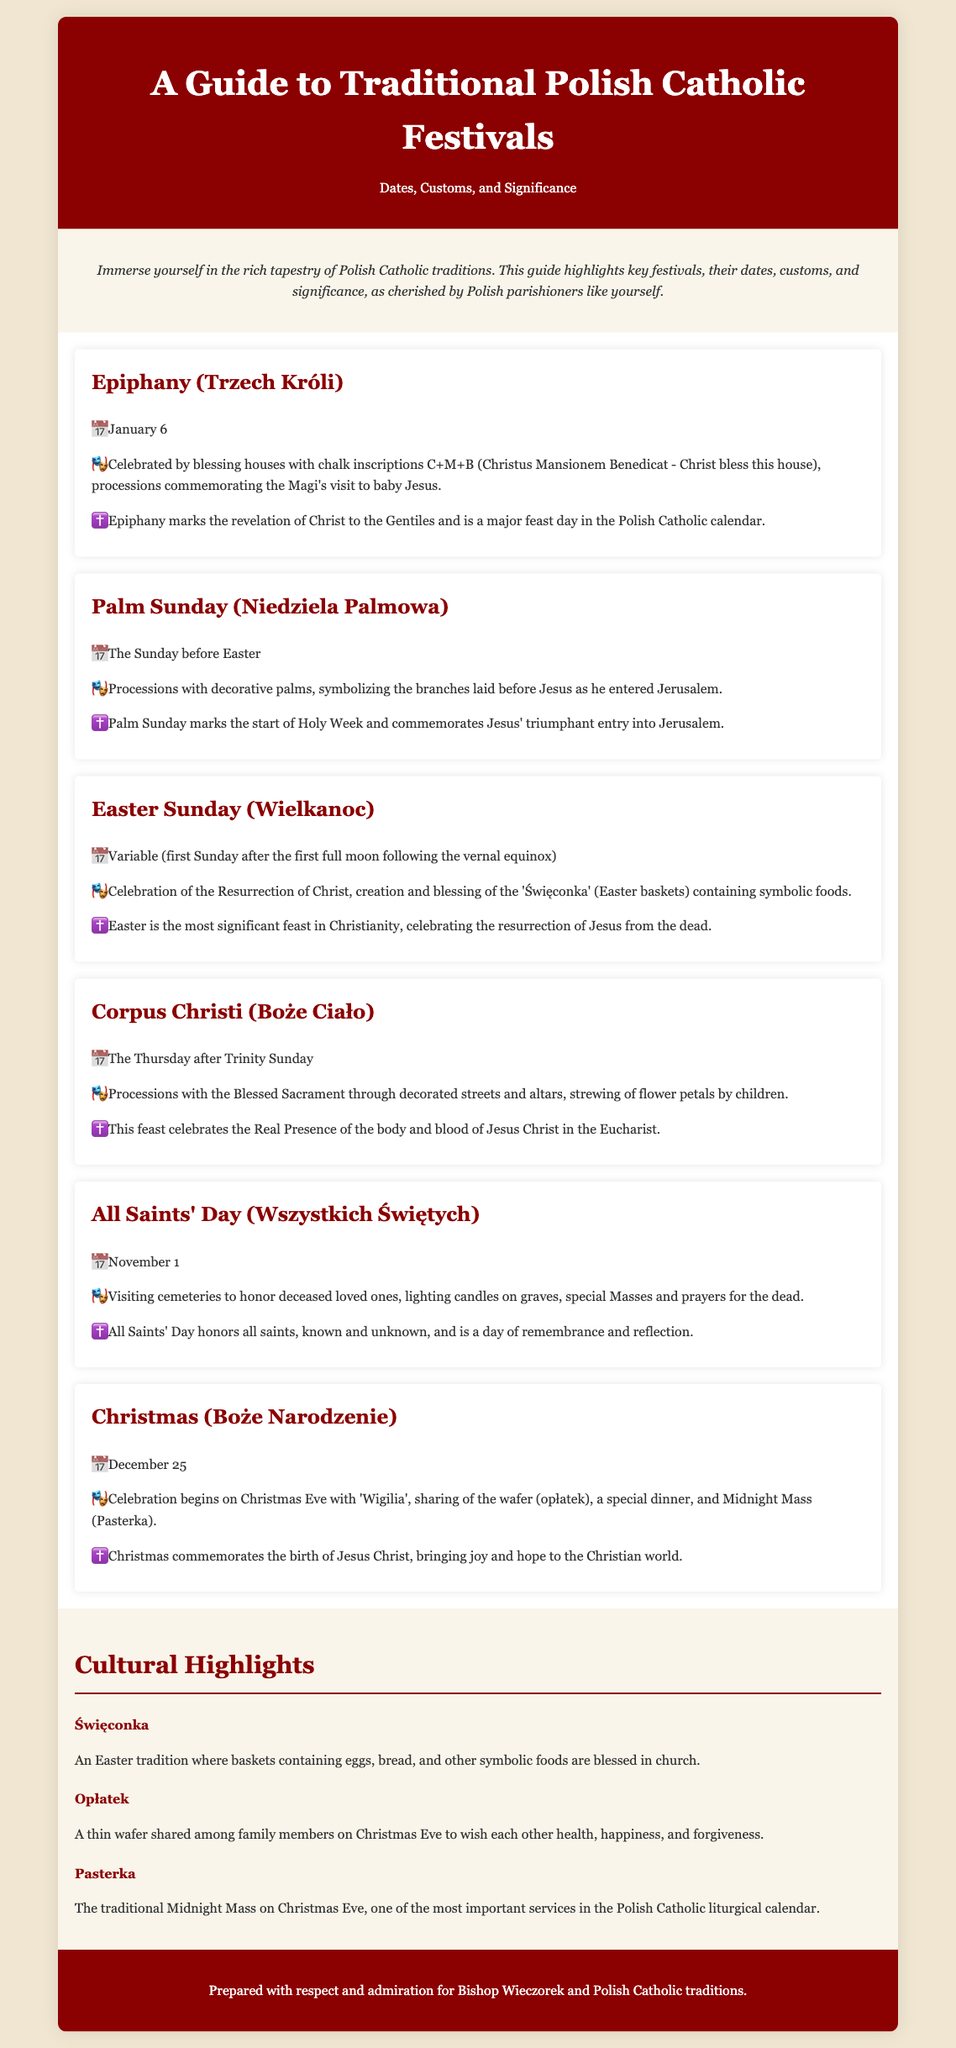What date is Epiphany celebrated? The date for Epiphany is mentioned as January 6 in the document.
Answer: January 6 What is the significance of Palm Sunday? The significance of Palm Sunday is explained as it marks the start of Holy Week and commemorates Jesus' triumphant entry into Jerusalem.
Answer: Start of Holy Week What do Polish families share on Christmas Eve? The document mentions that families share a thin wafer called 'opłatek' on Christmas Eve.
Answer: Opłatek When is All Saints' Day observed? The document specifies that All Saints' Day is observed on November 1.
Answer: November 1 What tradition involves blessings of Easter baskets? The tradition involving blessings of Easter baskets is referred to as 'Święconka' in the document.
Answer: Święconka What does the "C+M+B" inscription stand for? The document explains that "C+M+B" stands for "Christus Mansionem Benedicat."
Answer: Christus Mansionem Benedicat Which festival includes Midnight Mass? The document states that Christmas (Boże Narodzenie) includes Midnight Mass.
Answer: Christmas What do children do during the Corpus Christi procession? The document describes that children strew flower petals during the Corpus Christi procession.
Answer: Strew flower petals What are the three cultural highlights mentioned? The document lists three cultural highlights: Święconka, Opłatek, and Pasterka.
Answer: Święconka, Opłatek, Pasterka 